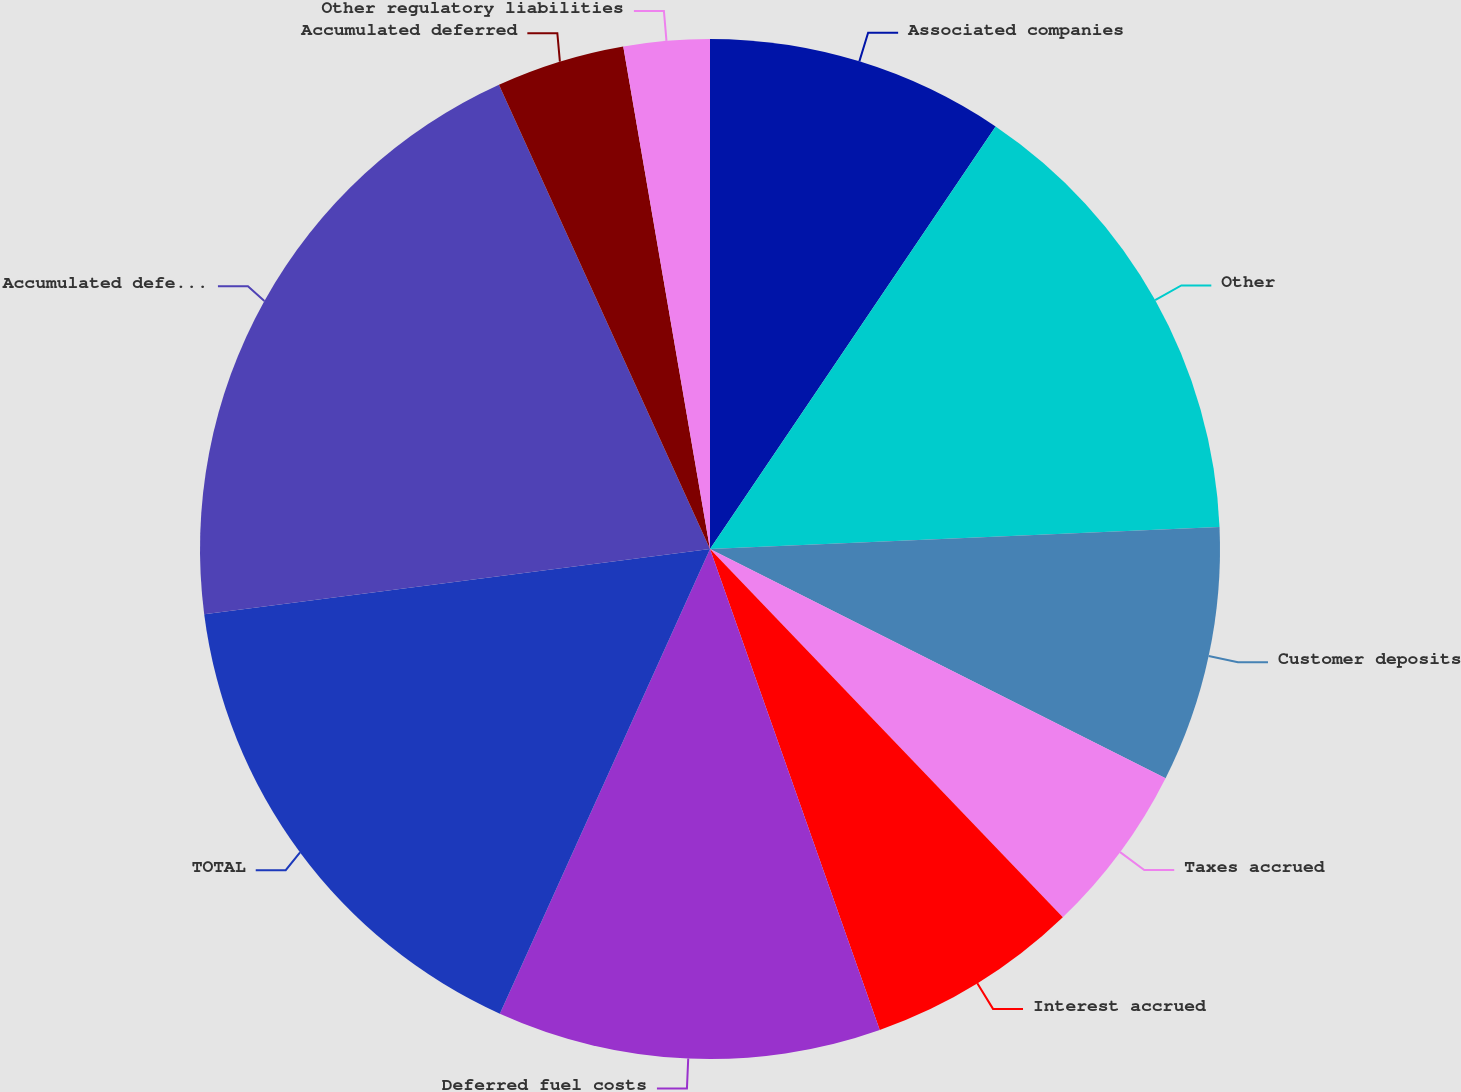Convert chart to OTSL. <chart><loc_0><loc_0><loc_500><loc_500><pie_chart><fcel>Associated companies<fcel>Other<fcel>Customer deposits<fcel>Taxes accrued<fcel>Interest accrued<fcel>Deferred fuel costs<fcel>TOTAL<fcel>Accumulated deferred income<fcel>Accumulated deferred<fcel>Other regulatory liabilities<nl><fcel>9.46%<fcel>14.85%<fcel>8.11%<fcel>5.42%<fcel>6.76%<fcel>12.16%<fcel>16.2%<fcel>20.25%<fcel>4.07%<fcel>2.72%<nl></chart> 